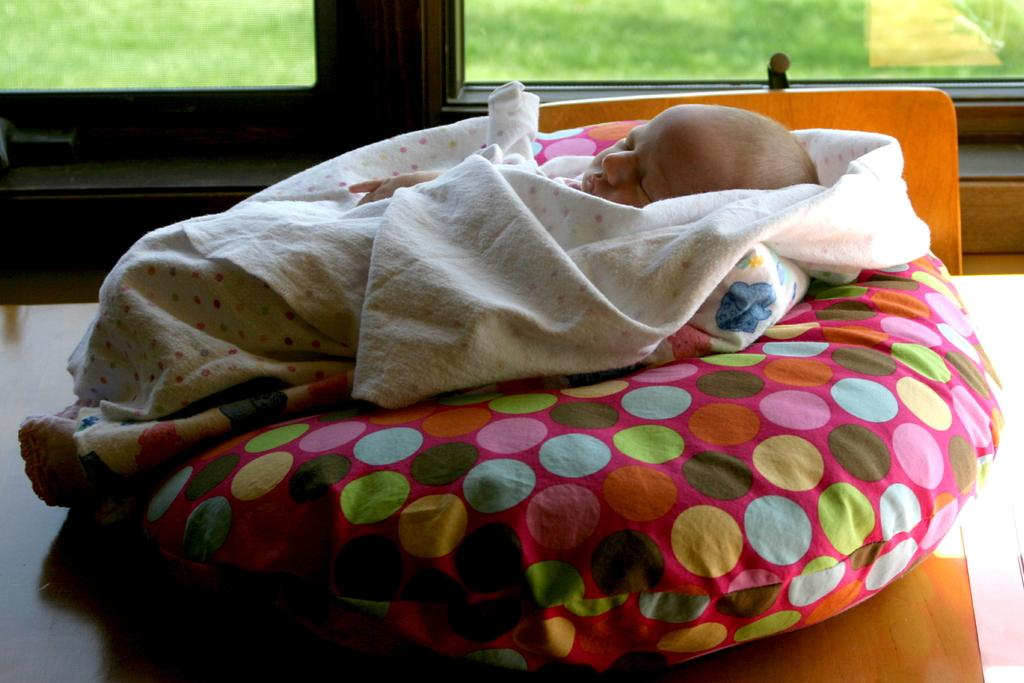What is the main subject of the image? There is a baby in the image. What is the baby doing in the image? The baby is sleeping. Where is the baby located in the image? The baby is on a bed. What type of dog is playing with the baby in the image? There is no dog present in the image; the baby is sleeping on a bed. 